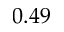<formula> <loc_0><loc_0><loc_500><loc_500>0 . 4 9</formula> 